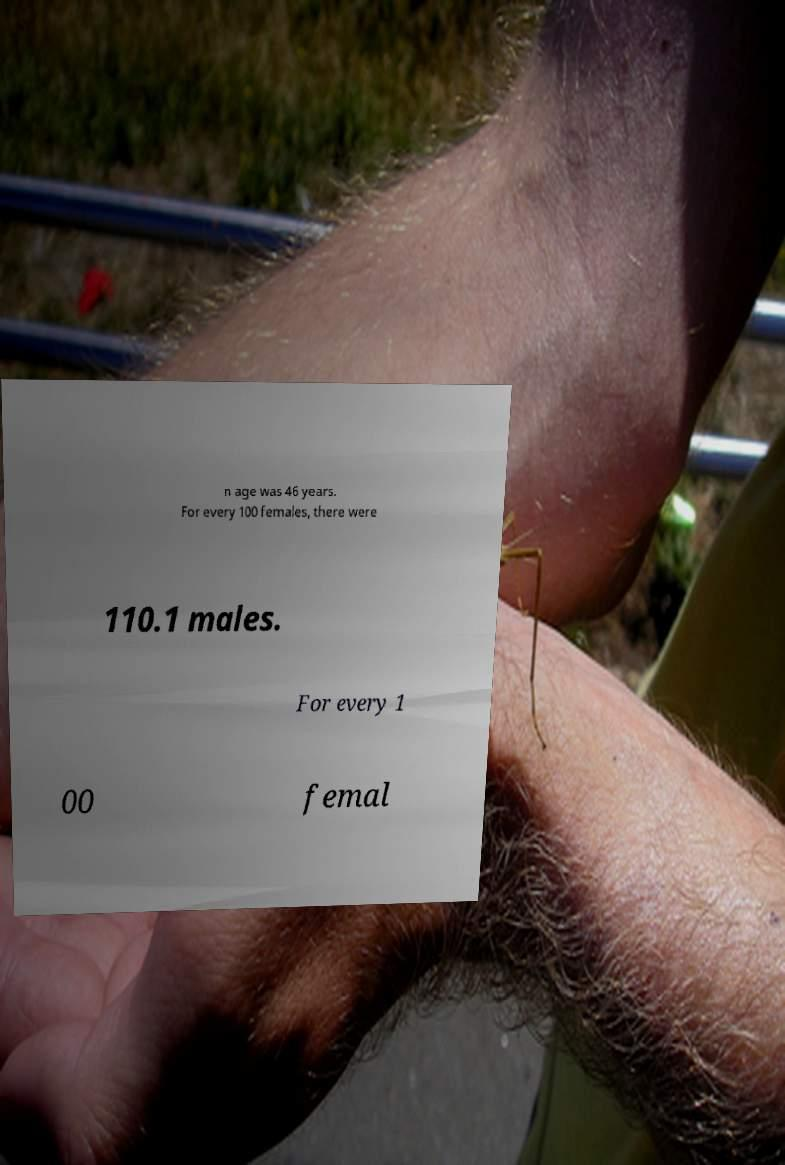Could you extract and type out the text from this image? n age was 46 years. For every 100 females, there were 110.1 males. For every 1 00 femal 